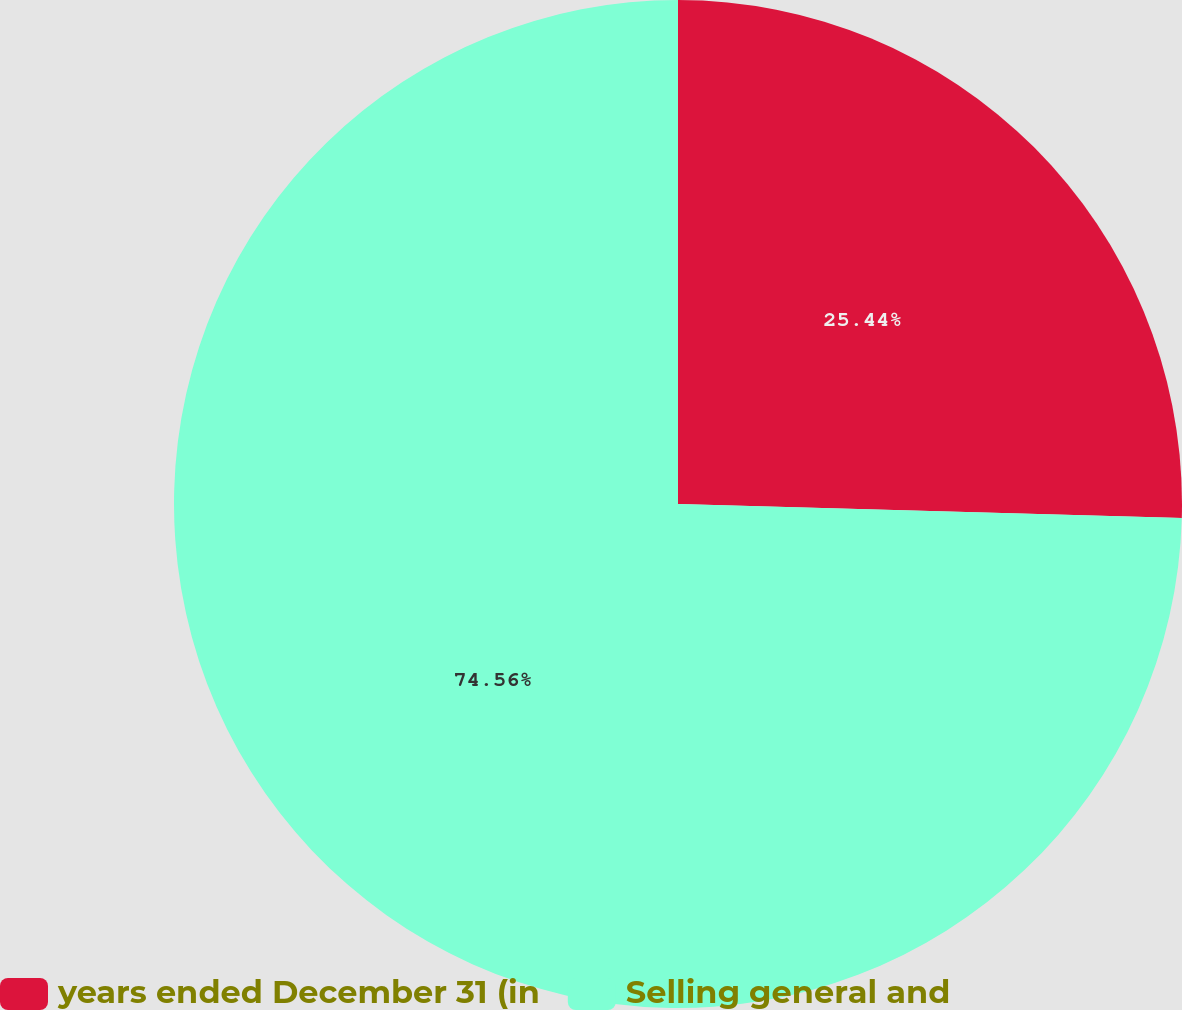<chart> <loc_0><loc_0><loc_500><loc_500><pie_chart><fcel>years ended December 31 (in<fcel>Selling general and<nl><fcel>25.44%<fcel>74.56%<nl></chart> 